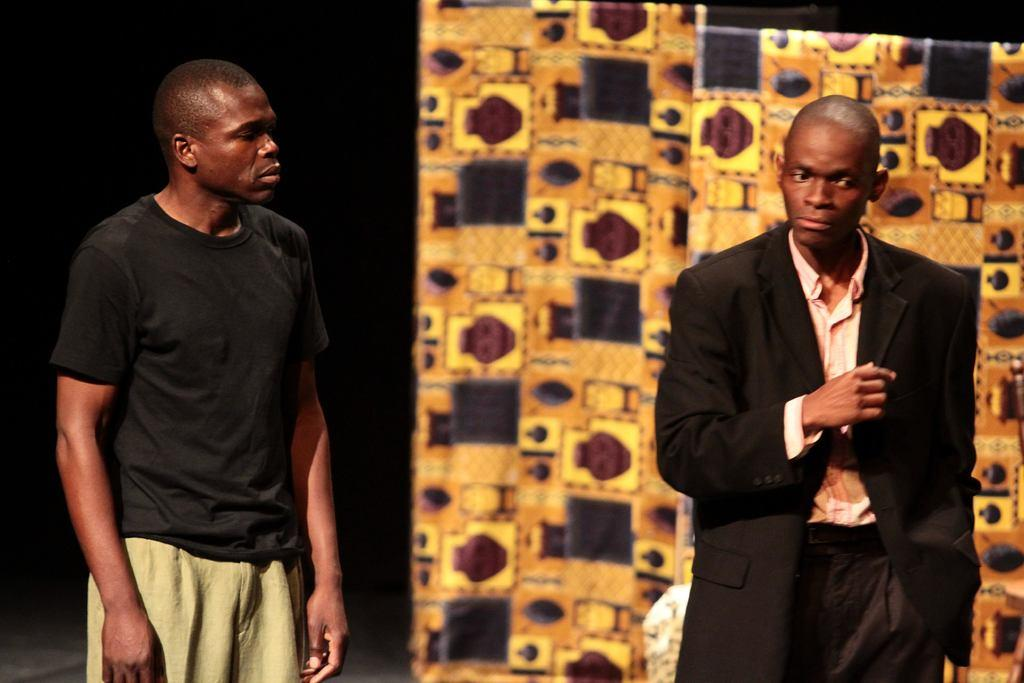How many people are present in the image? There are two men standing in the image. What can be seen in the background of the image? There is a yellow color poster in the background. Can you describe the lighting on the left side of the background? The left side of the background appears to be dark. What type of beef is being served in the image? There is no beef present in the image. How do the two men say good-bye to each other in the image? The image does not show the men saying good-bye to each other. 